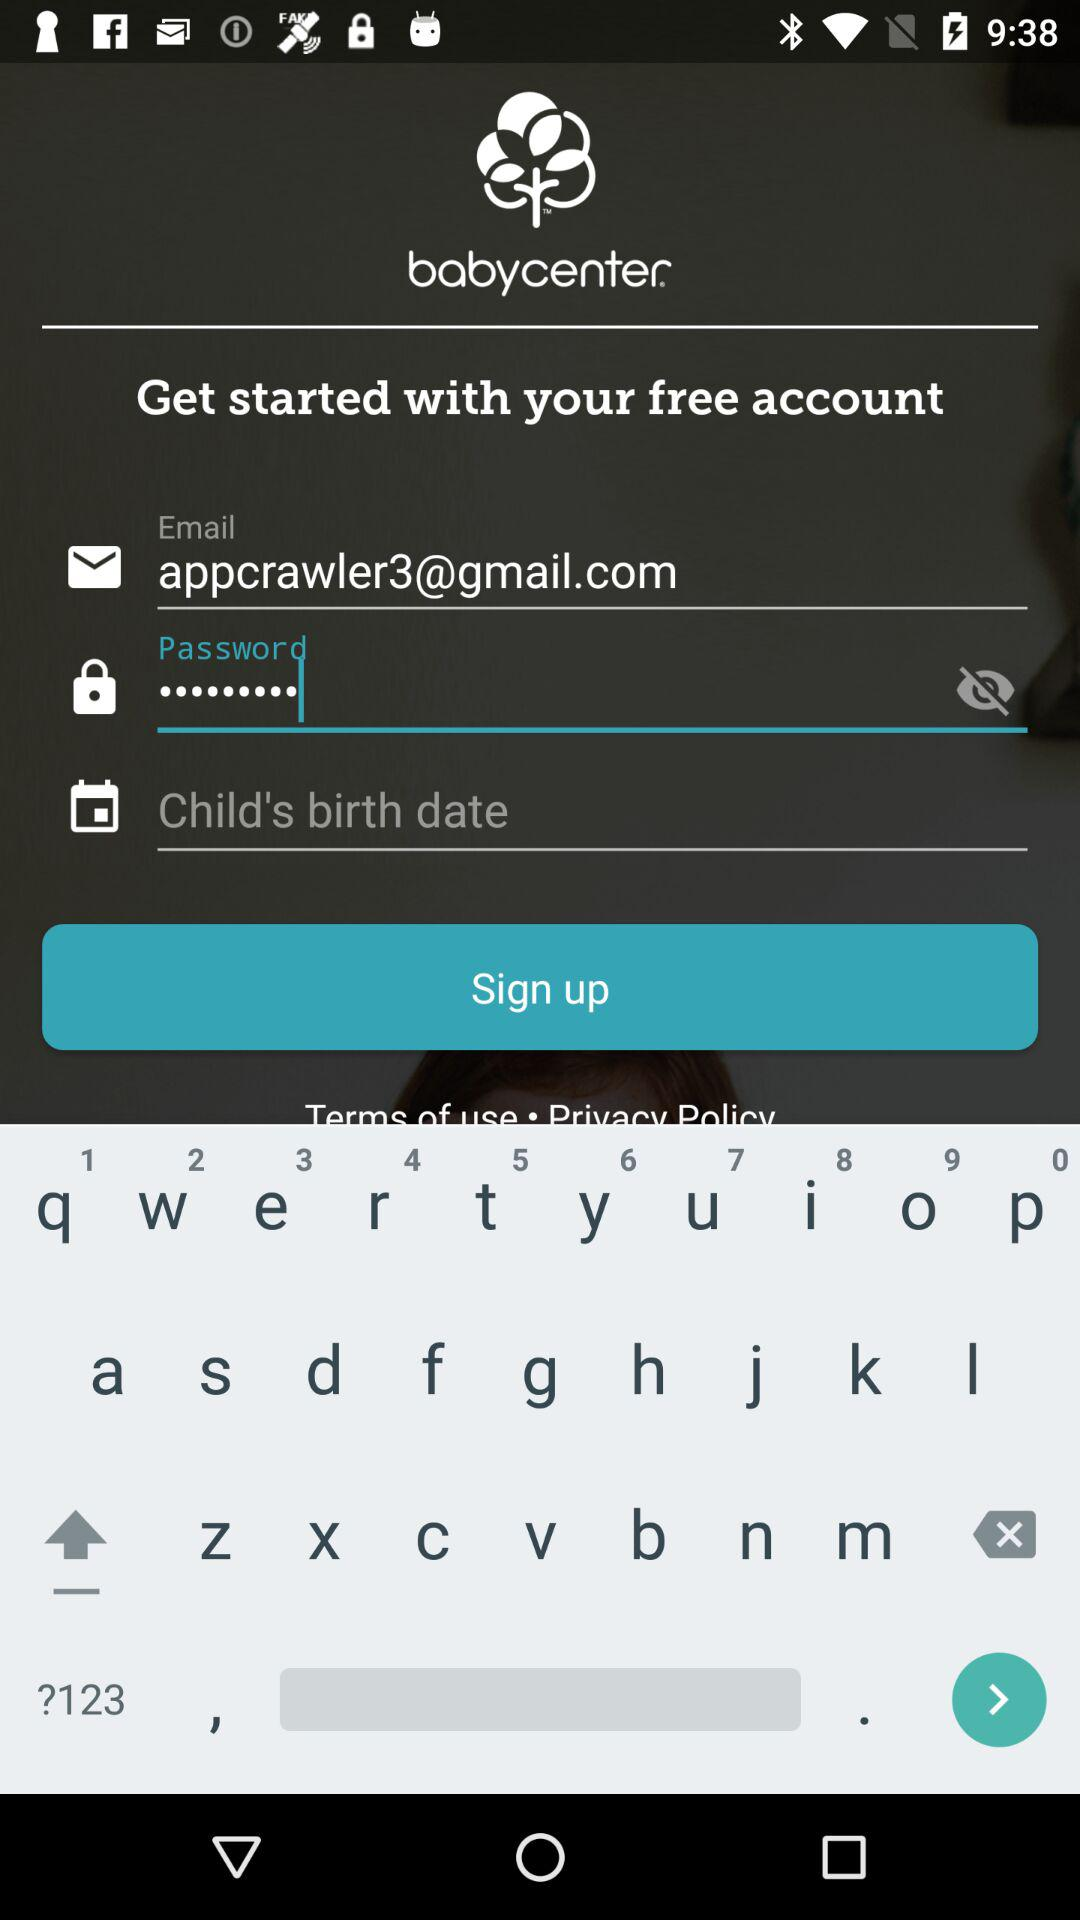How many fields are there in the form?
Answer the question using a single word or phrase. 3 